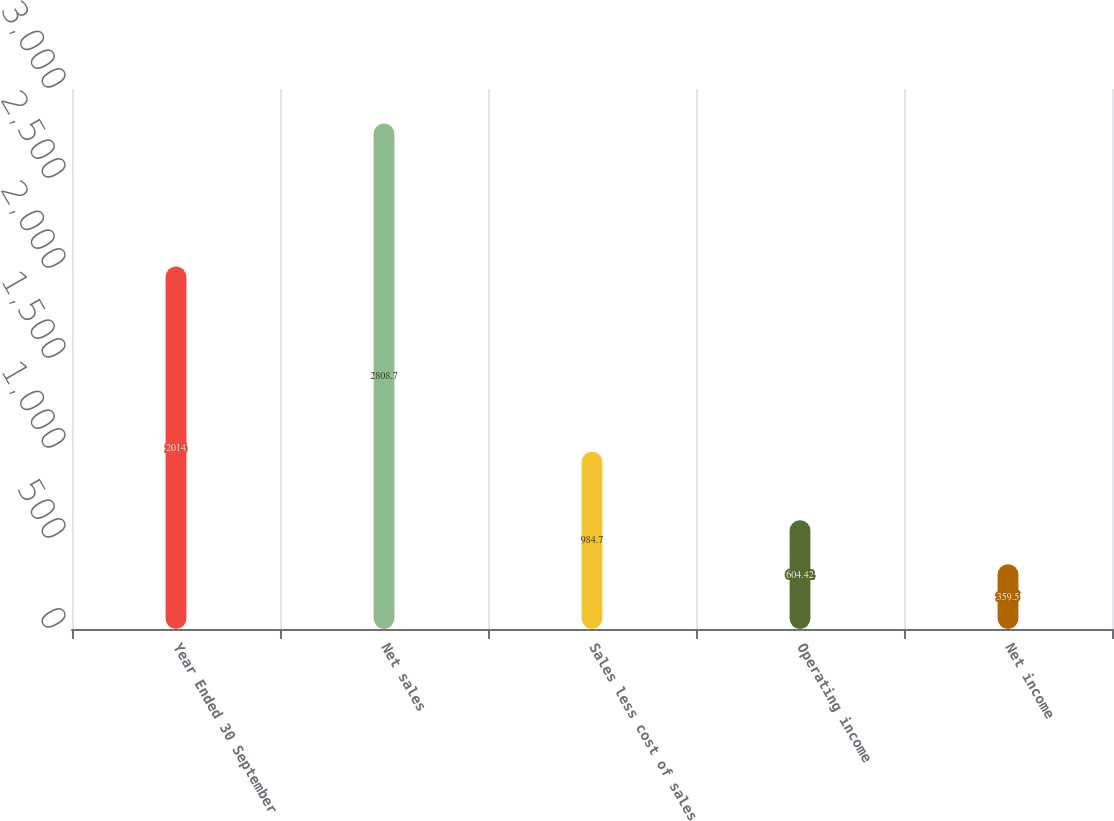Convert chart. <chart><loc_0><loc_0><loc_500><loc_500><bar_chart><fcel>Year Ended 30 September<fcel>Net sales<fcel>Sales less cost of sales<fcel>Operating income<fcel>Net income<nl><fcel>2014<fcel>2808.7<fcel>984.7<fcel>604.42<fcel>359.5<nl></chart> 